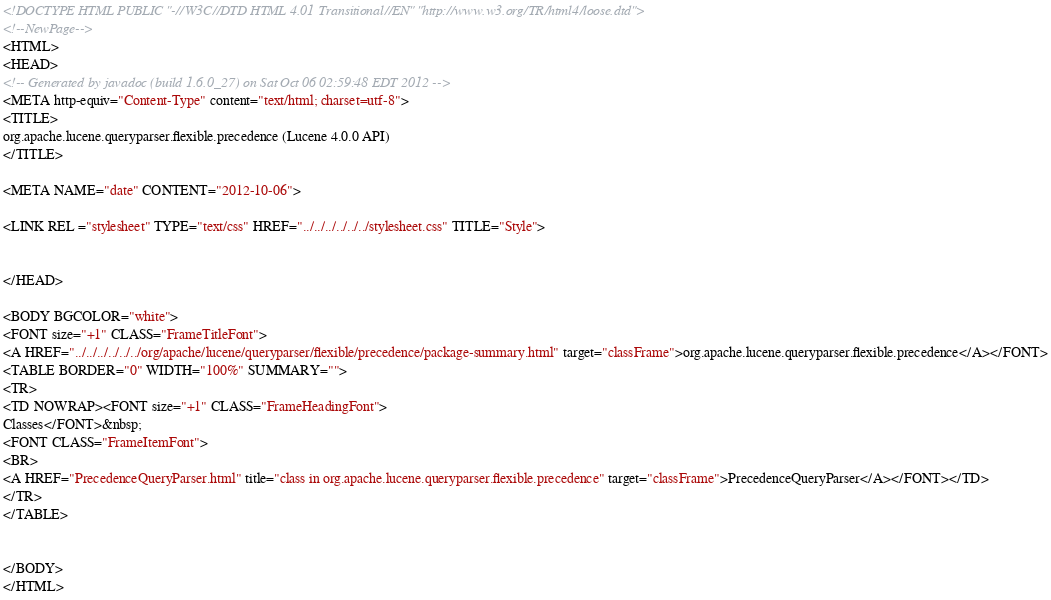<code> <loc_0><loc_0><loc_500><loc_500><_HTML_><!DOCTYPE HTML PUBLIC "-//W3C//DTD HTML 4.01 Transitional//EN" "http://www.w3.org/TR/html4/loose.dtd">
<!--NewPage-->
<HTML>
<HEAD>
<!-- Generated by javadoc (build 1.6.0_27) on Sat Oct 06 02:59:48 EDT 2012 -->
<META http-equiv="Content-Type" content="text/html; charset=utf-8">
<TITLE>
org.apache.lucene.queryparser.flexible.precedence (Lucene 4.0.0 API)
</TITLE>

<META NAME="date" CONTENT="2012-10-06">

<LINK REL ="stylesheet" TYPE="text/css" HREF="../../../../../../stylesheet.css" TITLE="Style">


</HEAD>

<BODY BGCOLOR="white">
<FONT size="+1" CLASS="FrameTitleFont">
<A HREF="../../../../../../org/apache/lucene/queryparser/flexible/precedence/package-summary.html" target="classFrame">org.apache.lucene.queryparser.flexible.precedence</A></FONT>
<TABLE BORDER="0" WIDTH="100%" SUMMARY="">
<TR>
<TD NOWRAP><FONT size="+1" CLASS="FrameHeadingFont">
Classes</FONT>&nbsp;
<FONT CLASS="FrameItemFont">
<BR>
<A HREF="PrecedenceQueryParser.html" title="class in org.apache.lucene.queryparser.flexible.precedence" target="classFrame">PrecedenceQueryParser</A></FONT></TD>
</TR>
</TABLE>


</BODY>
</HTML>
</code> 